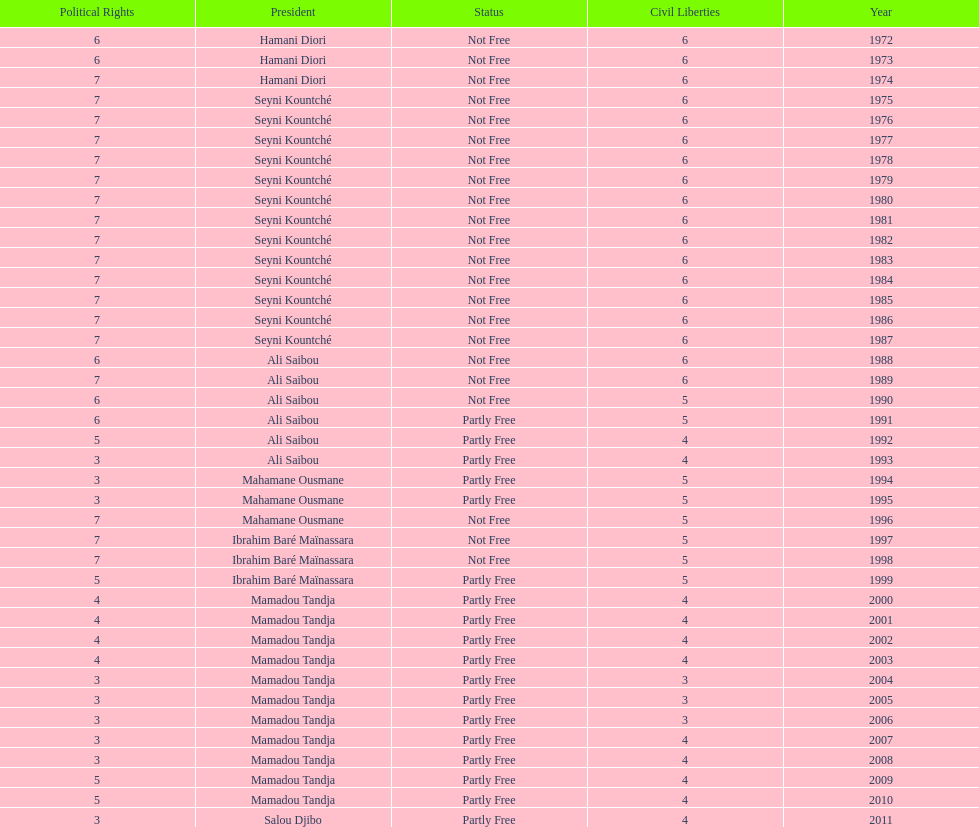Who was president before mamadou tandja? Ibrahim Baré Maïnassara. 